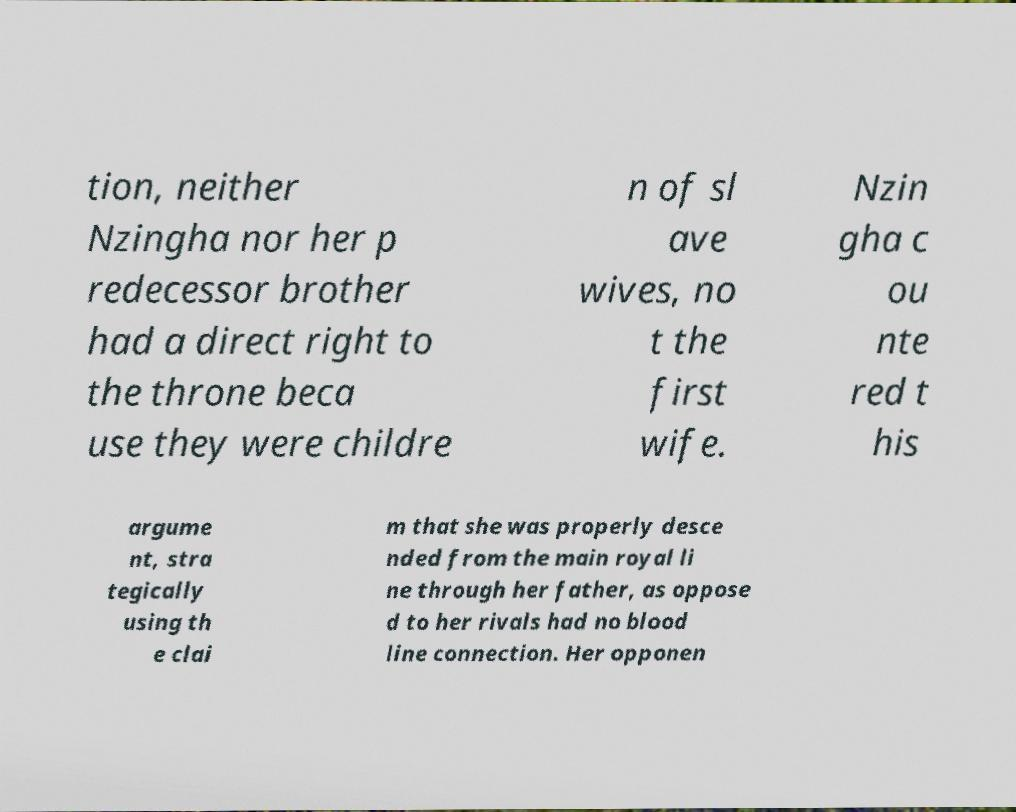Can you read and provide the text displayed in the image?This photo seems to have some interesting text. Can you extract and type it out for me? tion, neither Nzingha nor her p redecessor brother had a direct right to the throne beca use they were childre n of sl ave wives, no t the first wife. Nzin gha c ou nte red t his argume nt, stra tegically using th e clai m that she was properly desce nded from the main royal li ne through her father, as oppose d to her rivals had no blood line connection. Her opponen 